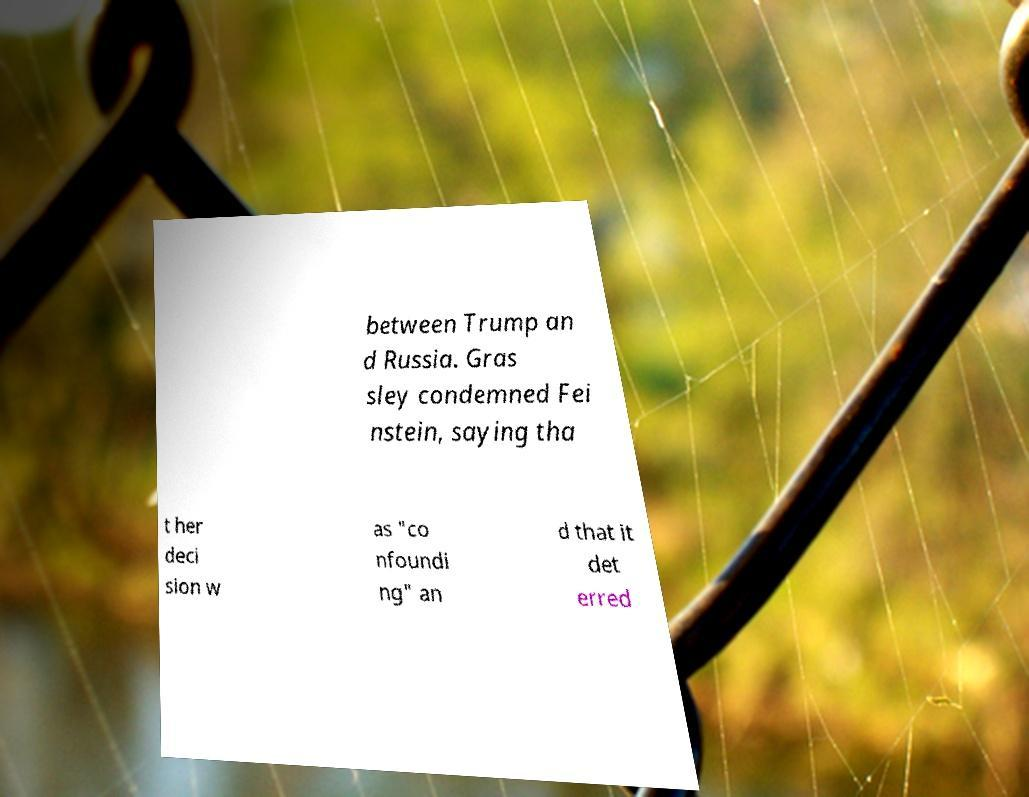Could you assist in decoding the text presented in this image and type it out clearly? between Trump an d Russia. Gras sley condemned Fei nstein, saying tha t her deci sion w as "co nfoundi ng" an d that it det erred 